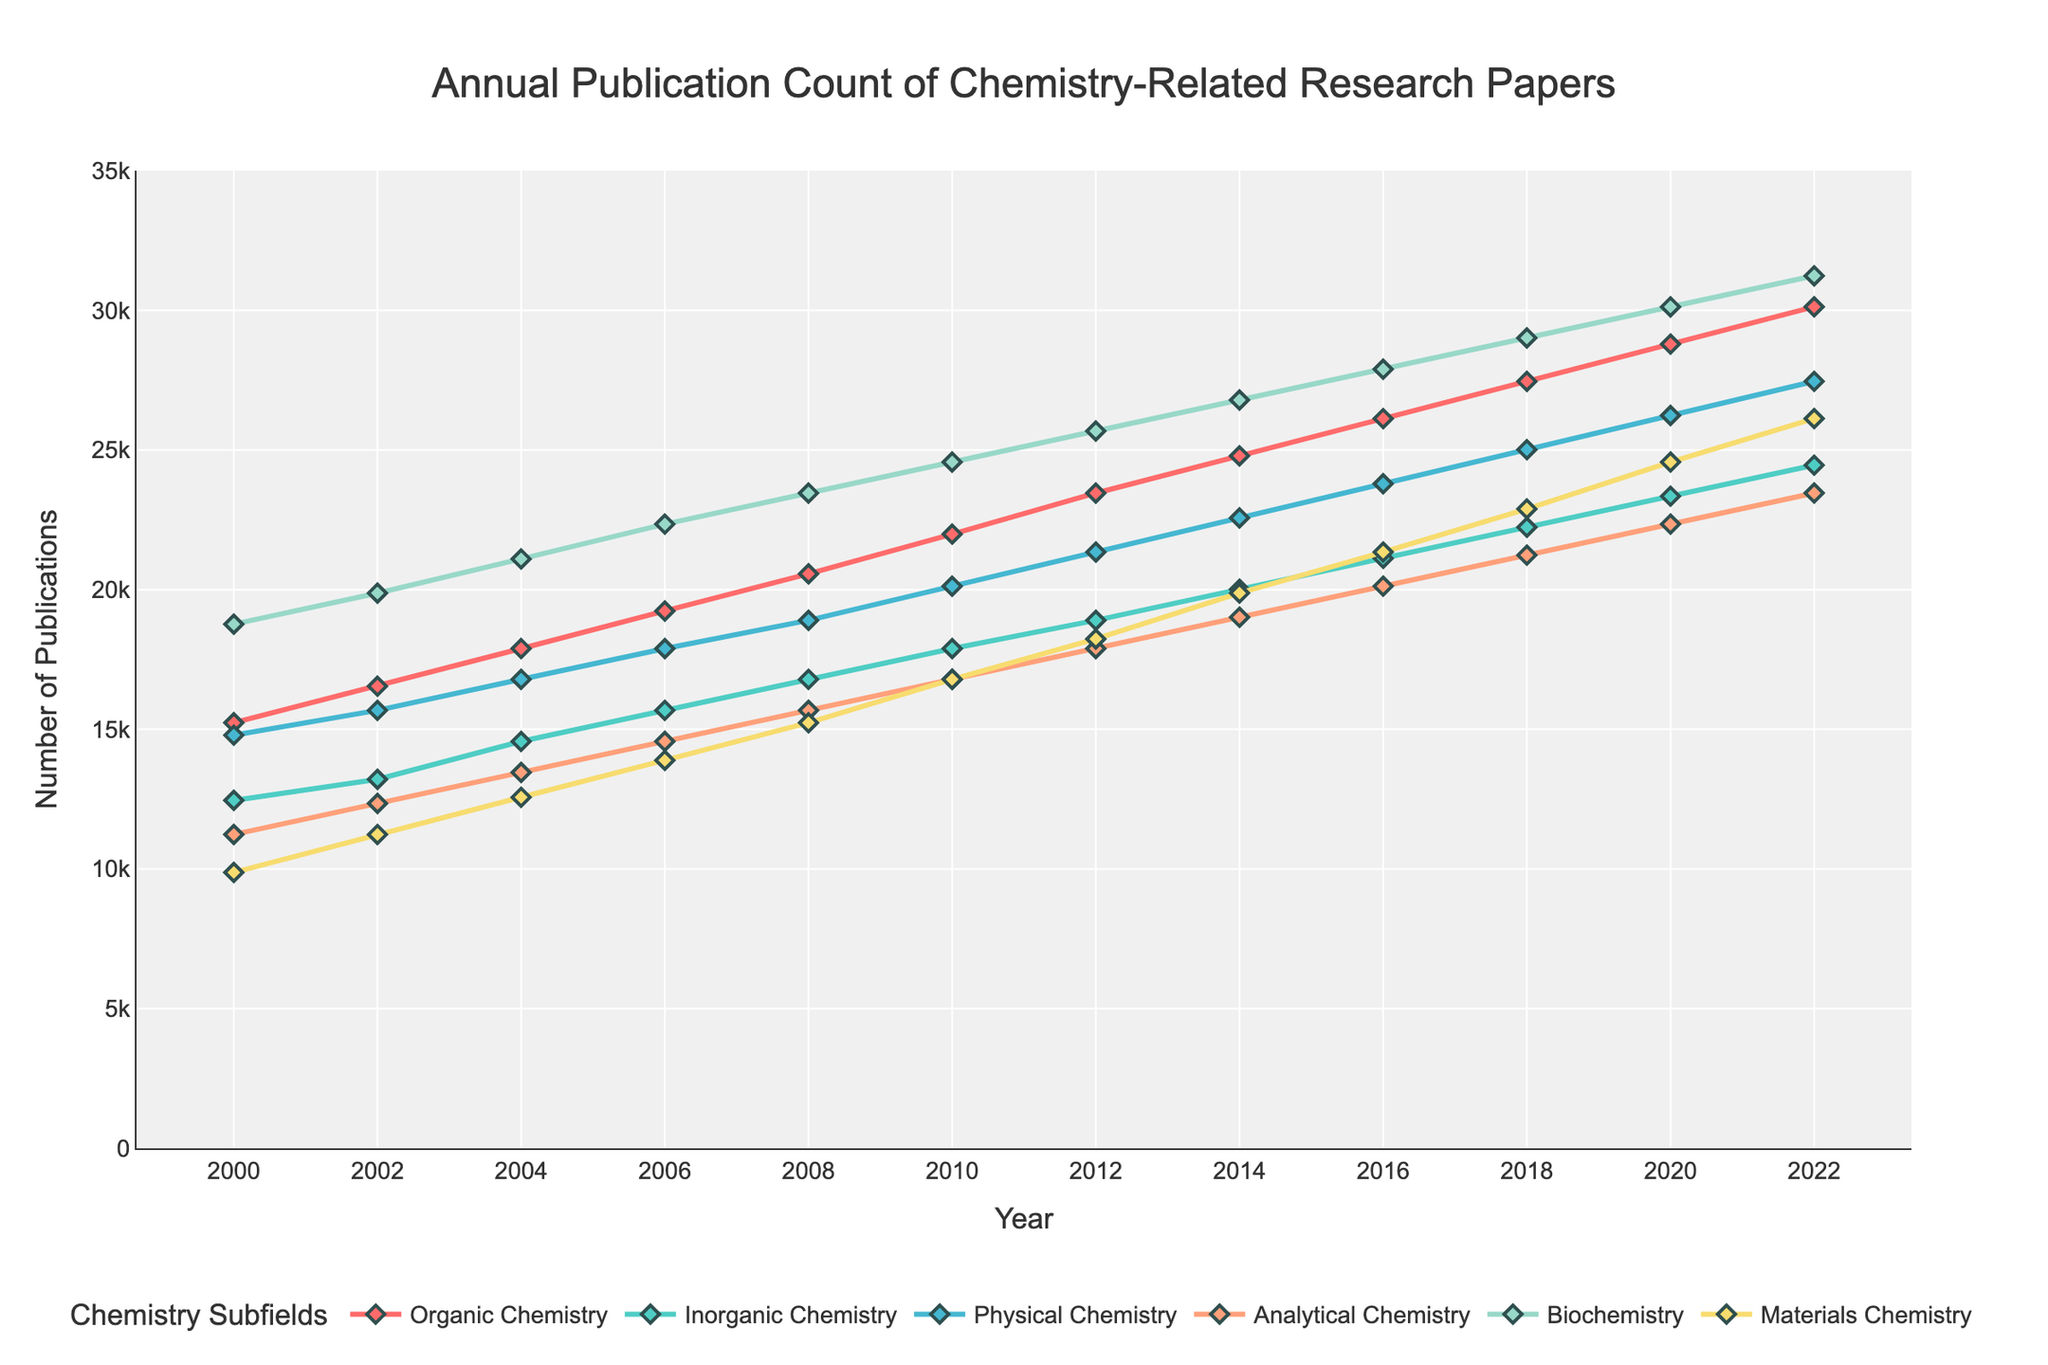What's the trend in the number of publications in Organic Chemistry from 2000 to 2022? From the figure, the number of publications in Organic Chemistry shows a consistent upward trend from 2000 (15234 publications) to 2022 (30123 publications). By visual inspection, the line for Organic Chemistry steadily rises over the years.
Answer: Consistent upward trend Which subfield had the highest number of publications in 2022? According to the figure, Biochemistry had the highest number of publications in 2022 with a count of 31234 publications. This is visually represented by the highest point among all subfields in the year 2022.
Answer: Biochemistry had 31234 publications By how much did the publication count for Materials Chemistry increase from 2000 to 2022? The publication count for Materials Chemistry was 9876 in 2000 and rose to 26123 in 2022. The increase is calculated by subtracting the 2000 count from the 2022 count: 26123 - 9876 = 16247.
Answer: Increased by 16247 In which year did Physical Chemistry surpass 20000 publications? The figure shows that the line for Physical Chemistry crosses the 20000 publication mark between 2010 and 2012. Exact values show that in 2010, Physical Chemistry had 20123 publications.
Answer: 2010 Which year had the smallest difference between the number of publications in Analytical Chemistry and Organic Chemistry? By observing the two lines closely, the smallest difference appears between the years. Using exact values: in 2012, Analytical Chemistry had 17890 publications and Organic Chemistry had 23456 publications. The difference is
Answer: Comparing the differences year by year, let's calculate some sample differences: (2022: 30123 - 23456, 2018: 27456 - 21234) Which subfield showed the least growth in publication numbers from 2000 to 2022? By visually comparing the steepness of each line from 2000 to 2022, Inorganic Chemistry appears to have the least growth. Quantitatively, Inorganic Chemistry grew from 12456 in 2000 to 24456 in 2022, an increase of only 12000 publications, which seems lowest among all subfields.
Answer: Inorganic Chemistry What's the average number of publications per year for Biochemistry from 2000 to 2022? The average is calculated by summing up the total number of publications for Biochemistry from 2000 to 2022 and then dividing by the total number of years (2022 - 2000 + 1 = 23 years). Sum of Biochemistry publications: 18765 + 19876 + 21098 + 22345 + 23456 + 24567 + 25678 + 26789 + 27890 + 29012 + 30123 + 31234 = 300833. Average = 300833 / 23 ≈ 130793.
Answer: 130793 Which subfield consistently remained the lowest contributor to publication counts from 2000 to 2022? By visually inspecting, Materials Chemistry consistently shows the lowest publication counts over the years, as its trajectory lies at the bottom compared to other subfields.
Answer: Materials Chemistry 